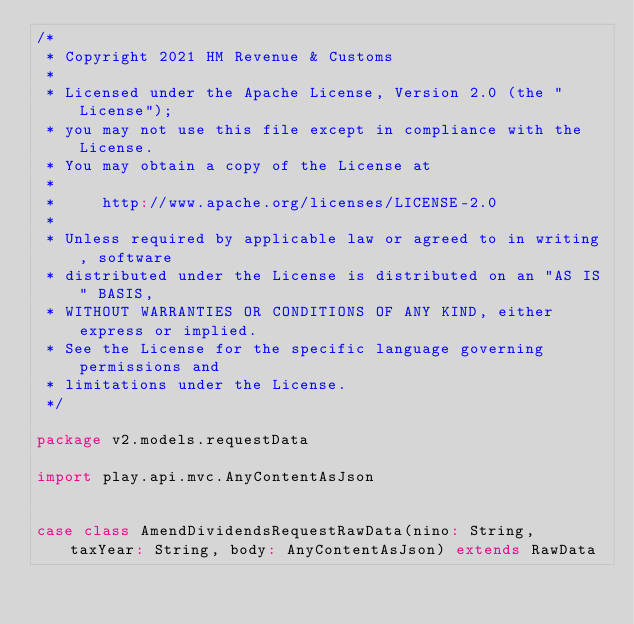<code> <loc_0><loc_0><loc_500><loc_500><_Scala_>/*
 * Copyright 2021 HM Revenue & Customs
 *
 * Licensed under the Apache License, Version 2.0 (the "License");
 * you may not use this file except in compliance with the License.
 * You may obtain a copy of the License at
 *
 *     http://www.apache.org/licenses/LICENSE-2.0
 *
 * Unless required by applicable law or agreed to in writing, software
 * distributed under the License is distributed on an "AS IS" BASIS,
 * WITHOUT WARRANTIES OR CONDITIONS OF ANY KIND, either express or implied.
 * See the License for the specific language governing permissions and
 * limitations under the License.
 */

package v2.models.requestData

import play.api.mvc.AnyContentAsJson


case class AmendDividendsRequestRawData(nino: String, taxYear: String, body: AnyContentAsJson) extends RawData
</code> 